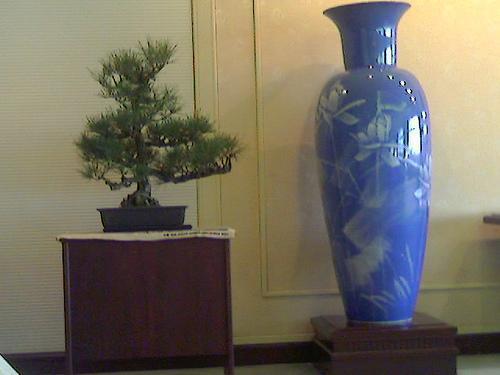How many people have a blue and white striped shirt?
Give a very brief answer. 0. 